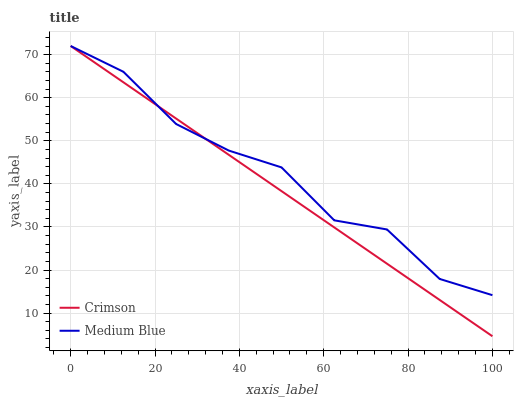Does Crimson have the minimum area under the curve?
Answer yes or no. Yes. Does Medium Blue have the maximum area under the curve?
Answer yes or no. Yes. Does Medium Blue have the minimum area under the curve?
Answer yes or no. No. Is Crimson the smoothest?
Answer yes or no. Yes. Is Medium Blue the roughest?
Answer yes or no. Yes. Is Medium Blue the smoothest?
Answer yes or no. No. Does Crimson have the lowest value?
Answer yes or no. Yes. Does Medium Blue have the lowest value?
Answer yes or no. No. Does Medium Blue have the highest value?
Answer yes or no. Yes. Does Medium Blue intersect Crimson?
Answer yes or no. Yes. Is Medium Blue less than Crimson?
Answer yes or no. No. Is Medium Blue greater than Crimson?
Answer yes or no. No. 